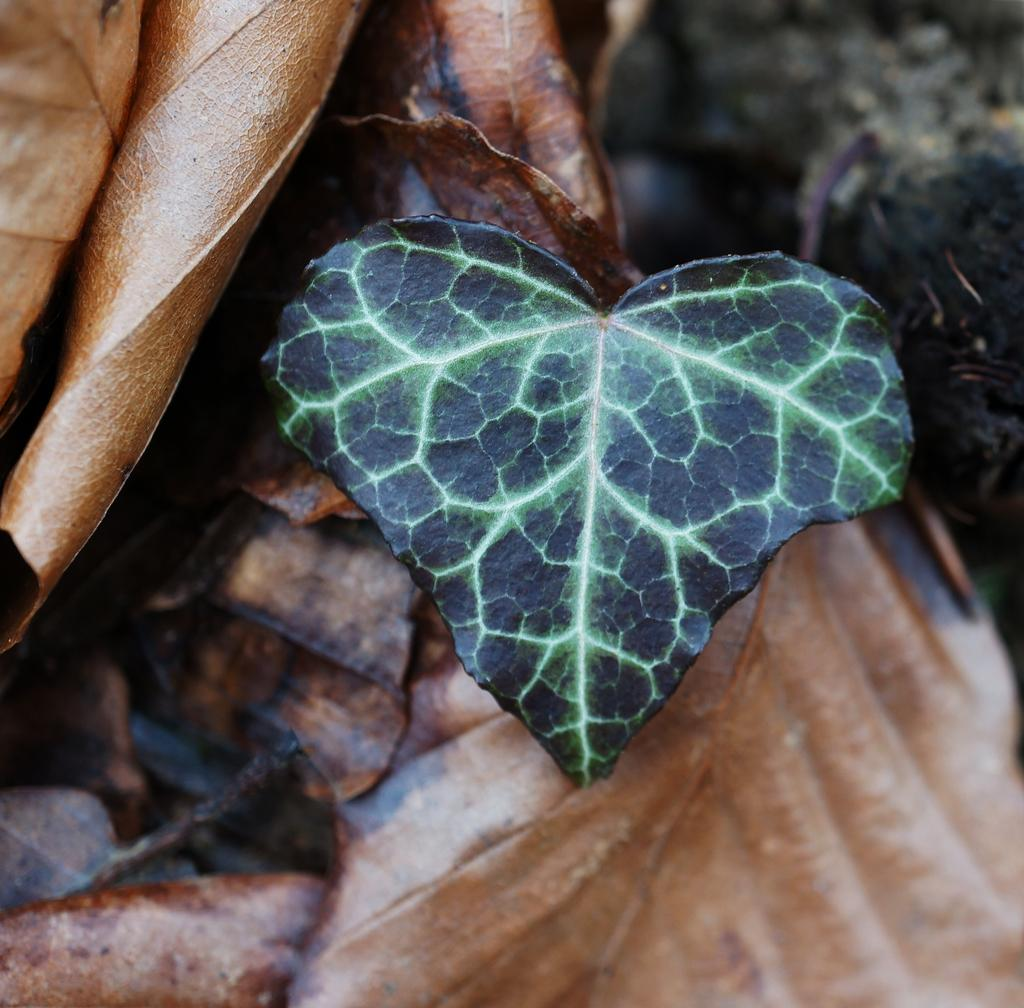What color are the leaves in the image? The leaves in the image are brown. What can be described as black and green in the image? There is a black and green color thing in the image. How would you describe the clarity of the image? The image is slightly blurry. Can you tell me how many chairs are visible in the image? There are no chairs present in the image. What type of creature can be seen interacting with the black and green color thing in the image? There is no creature present in the image; only the leaves and the black and green color thing are visible. 